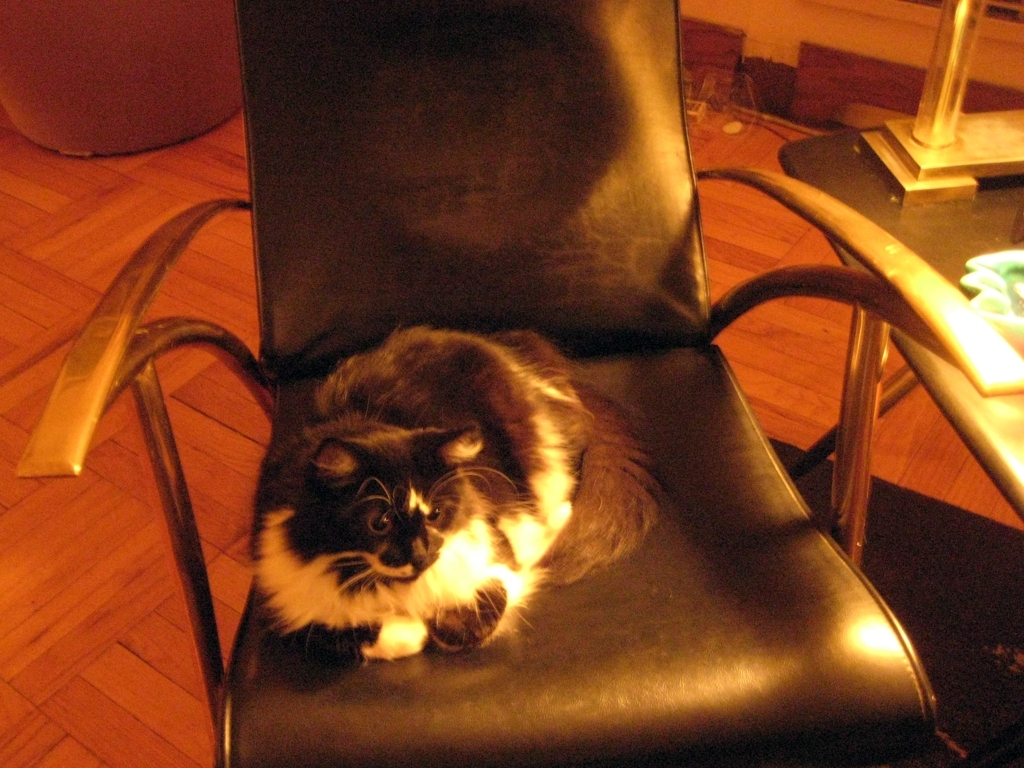How does the lighting affect the mood of this picture? The lighting casts a warm, soft glow which creates a cozy and serene atmosphere. It highlights the cat as the central focus and adds a sense of quietude to the scene. 